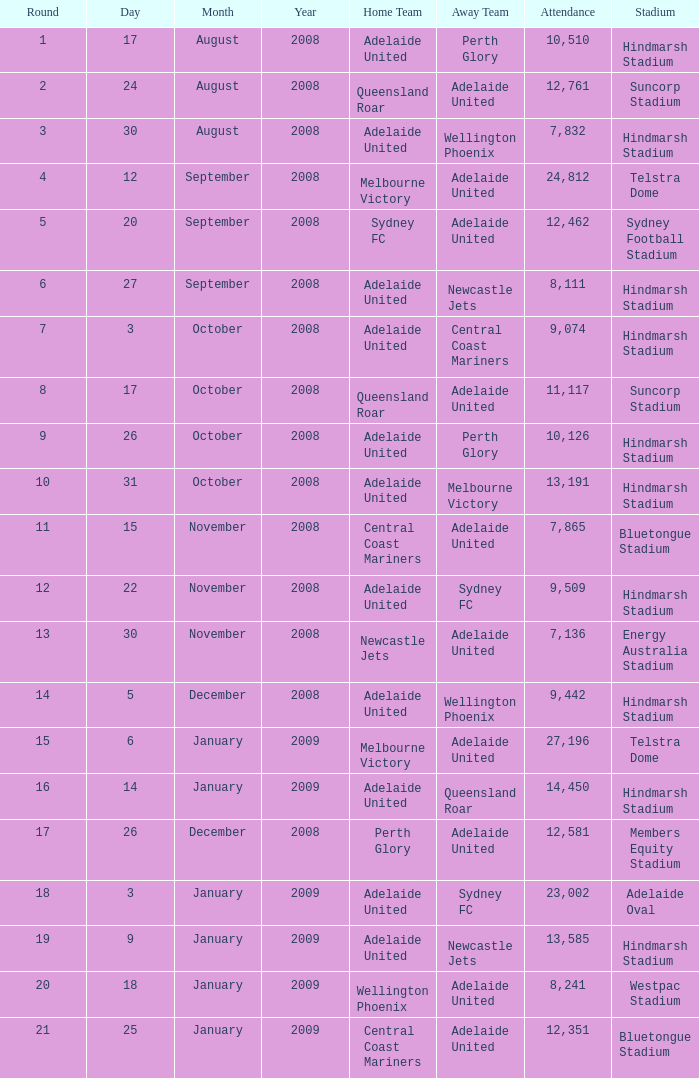What is the least round for the game played at Members Equity Stadium in from of 12,581 people? None. 